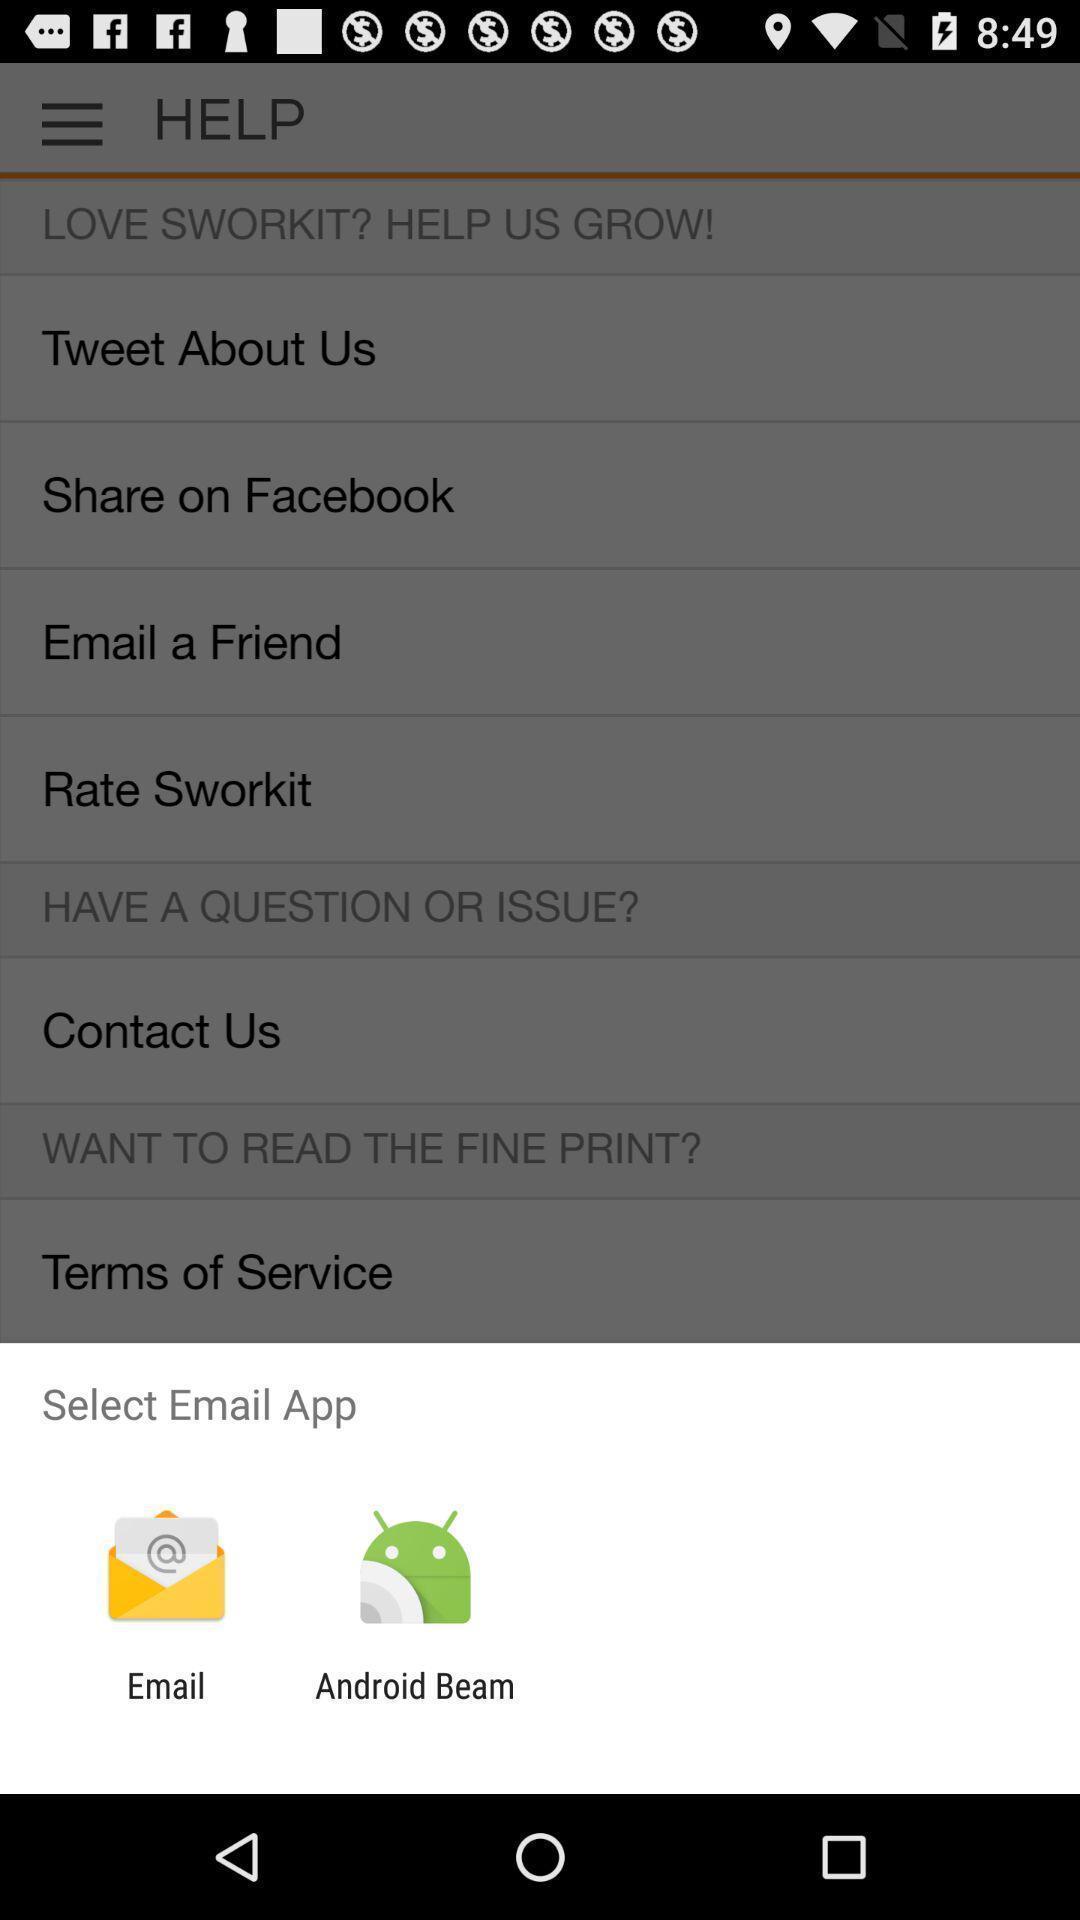Provide a description of this screenshot. Pop-up with options to select email app. 